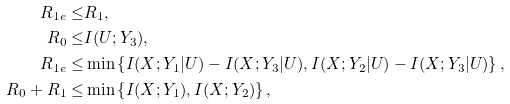<formula> <loc_0><loc_0><loc_500><loc_500>R _ { 1 e } \leq & R _ { 1 } , \\ R _ { 0 } \leq & I ( U ; Y _ { 3 } ) , \\ R _ { 1 e } \leq & \min \left \{ I ( X ; Y _ { 1 } | U ) - I ( X ; Y _ { 3 } | U ) , I ( X ; Y _ { 2 } | U ) - I ( X ; Y _ { 3 } | U ) \right \} , \\ R _ { 0 } + R _ { 1 } \leq & \min \left \{ I ( X ; Y _ { 1 } ) , I ( X ; Y _ { 2 } ) \right \} ,</formula> 